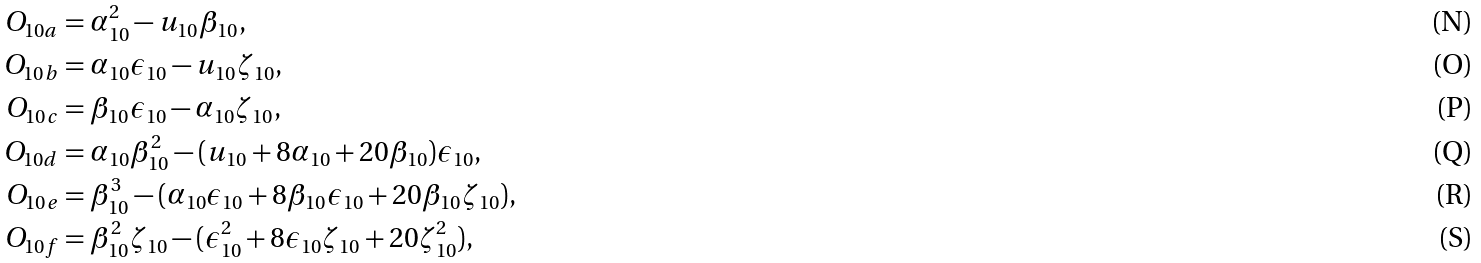Convert formula to latex. <formula><loc_0><loc_0><loc_500><loc_500>O _ { 1 0 a } & = \alpha _ { 1 0 } ^ { 2 } - u _ { 1 0 } \beta _ { 1 0 } , \\ O _ { 1 0 b } & = \alpha _ { 1 0 } \epsilon _ { 1 0 } - u _ { 1 0 } \zeta _ { 1 0 } , \\ O _ { 1 0 c } & = \beta _ { 1 0 } \epsilon _ { 1 0 } - \alpha _ { 1 0 } \zeta _ { 1 0 } , \\ O _ { 1 0 d } & = \alpha _ { 1 0 } \beta _ { 1 0 } ^ { 2 } - ( u _ { 1 0 } + 8 \alpha _ { 1 0 } + 2 0 \beta _ { 1 0 } ) \epsilon _ { 1 0 } , \\ O _ { 1 0 e } & = \beta _ { 1 0 } ^ { 3 } - ( \alpha _ { 1 0 } \epsilon _ { 1 0 } + 8 \beta _ { 1 0 } \epsilon _ { 1 0 } + 2 0 \beta _ { 1 0 } \zeta _ { 1 0 } ) , \\ O _ { 1 0 f } & = \beta _ { 1 0 } ^ { 2 } \zeta _ { 1 0 } - ( \epsilon _ { 1 0 } ^ { 2 } + 8 \epsilon _ { 1 0 } \zeta _ { 1 0 } + 2 0 \zeta _ { 1 0 } ^ { 2 } ) ,</formula> 